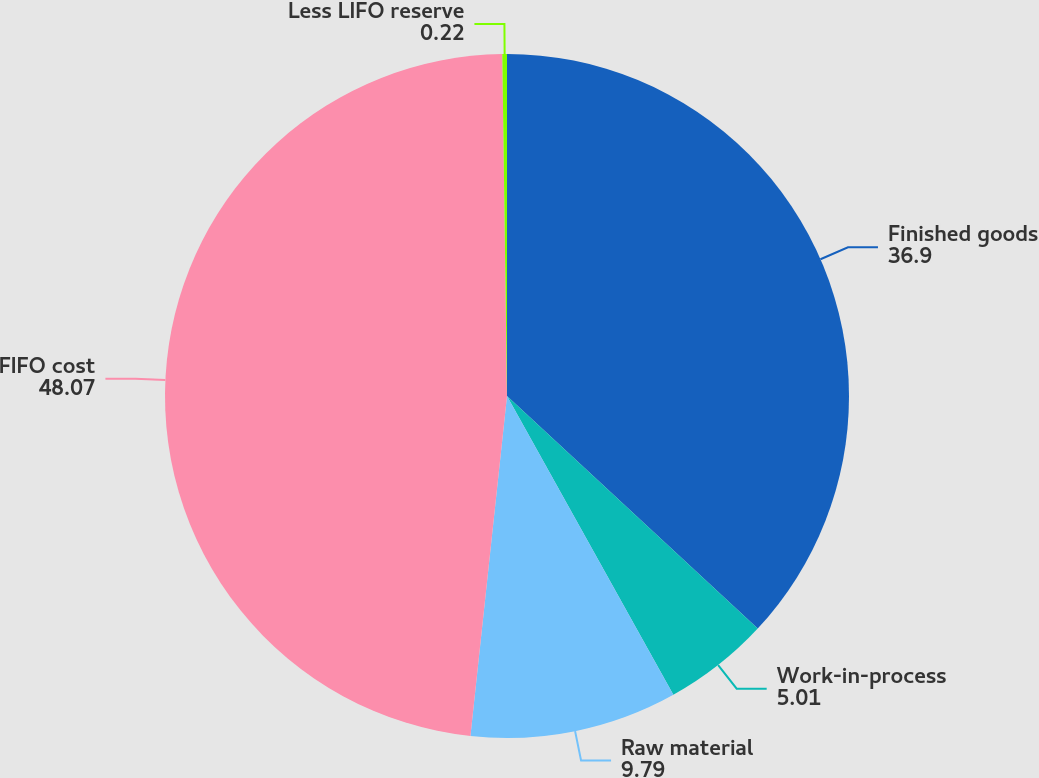Convert chart to OTSL. <chart><loc_0><loc_0><loc_500><loc_500><pie_chart><fcel>Finished goods<fcel>Work-in-process<fcel>Raw material<fcel>FIFO cost<fcel>Less LIFO reserve<nl><fcel>36.9%<fcel>5.01%<fcel>9.79%<fcel>48.07%<fcel>0.22%<nl></chart> 